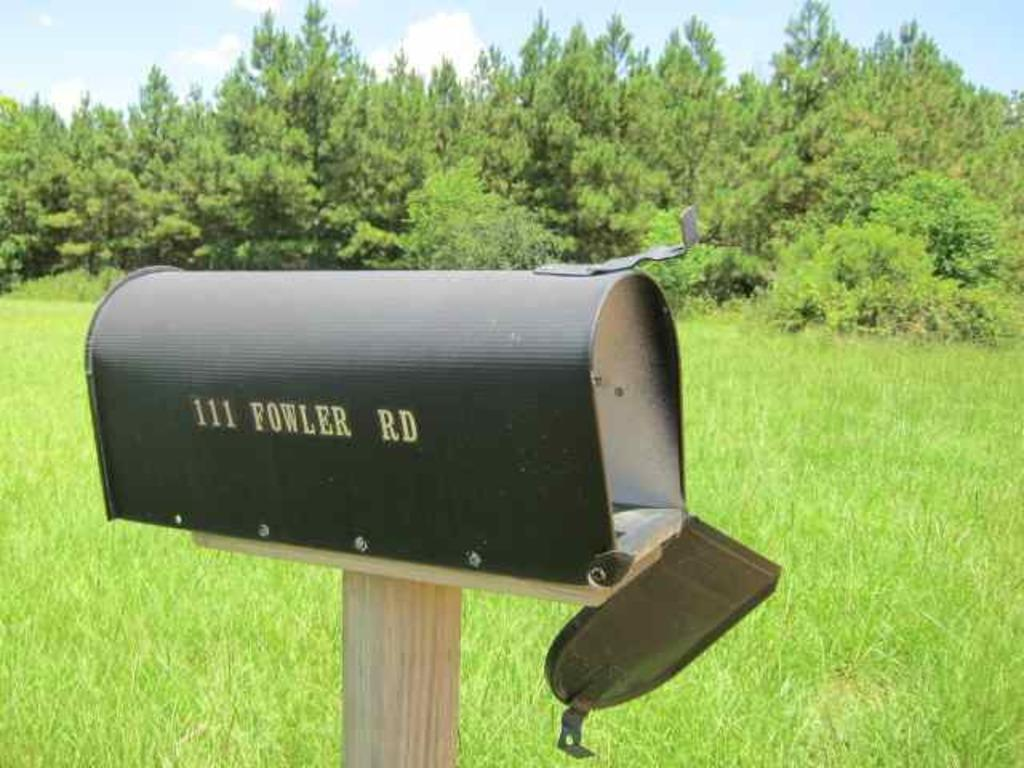What is the main subject in the center of the image? There is a post box in the center of the image. What can be seen on the post box? The post box has some text on it. What is visible in the background of the image? There is sky, clouds, trees, and grass visible in the background of the image. What type of house is being built with lumber in the image? There is no house or lumber being built in the image; it features a post box with a background of sky, clouds, trees, and grass. 